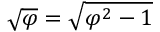<formula> <loc_0><loc_0><loc_500><loc_500>{ \sqrt { \varphi } } = { \sqrt { \varphi ^ { 2 } - 1 } }</formula> 